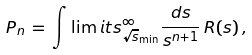<formula> <loc_0><loc_0><loc_500><loc_500>P _ { n } \, = \, \int \lim i t s ^ { \infty } _ { \sqrt { s } _ { \min } } \frac { d s } { s ^ { n + 1 } } \, R ( s ) \, ,</formula> 